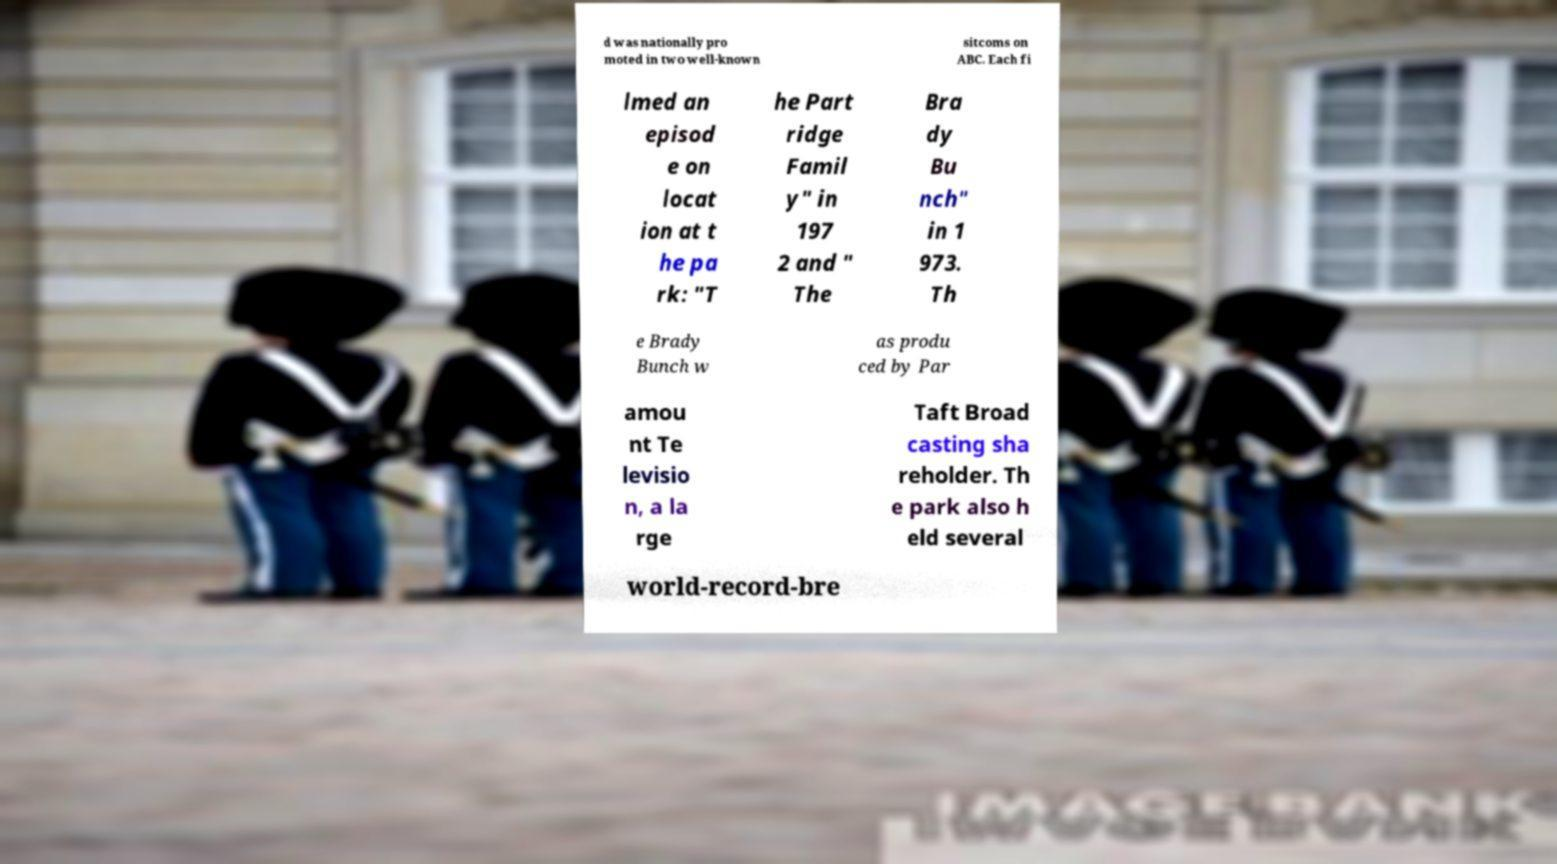There's text embedded in this image that I need extracted. Can you transcribe it verbatim? d was nationally pro moted in two well-known sitcoms on ABC. Each fi lmed an episod e on locat ion at t he pa rk: "T he Part ridge Famil y" in 197 2 and " The Bra dy Bu nch" in 1 973. Th e Brady Bunch w as produ ced by Par amou nt Te levisio n, a la rge Taft Broad casting sha reholder. Th e park also h eld several world-record-bre 